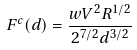Convert formula to latex. <formula><loc_0><loc_0><loc_500><loc_500>F ^ { c } ( d ) = \frac { w V ^ { 2 } R ^ { 1 / 2 } } { 2 ^ { 7 / 2 } d ^ { 3 / 2 } }</formula> 